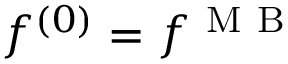<formula> <loc_0><loc_0><loc_500><loc_500>f ^ { ( 0 ) } = f ^ { M B }</formula> 